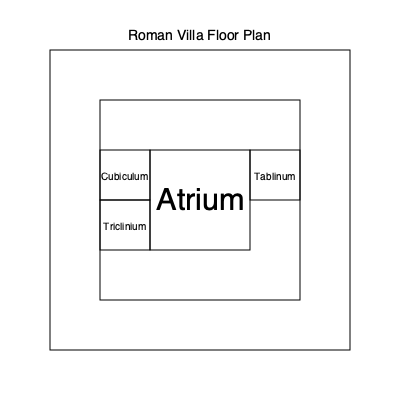Based on the provided floor plan of a Roman villa, which central room serves as the main reception area and typically contains an impluvium for collecting rainwater? To answer this question, let's analyze the floor plan step-by-step:

1. The floor plan shows a typical layout of a Roman villa with multiple rooms arranged around a central space.

2. The central and largest room in the floor plan is labeled "Atrium."

3. In Roman architecture, the atrium was the main reception area of the house and served multiple functions:
   a. It was the first room visitors would enter.
   b. It often contained an impluvium, a shallow pool designed to collect rainwater from the compluvium (an opening in the roof).
   c. It provided light and ventilation to the surrounding rooms.

4. Other rooms visible in the floor plan include:
   a. Tablinum: A smaller room off the atrium, typically used as the master's office or study.
   b. Cubiculum: A small room, usually used as a bedroom.
   c. Triclinium: The dining room in a Roman house.

5. The atrium's central location and larger size compared to other rooms indicate its importance in the villa's layout.

Given these observations, the room that serves as the main reception area and typically contains an impluvium for collecting rainwater is the atrium.
Answer: Atrium 